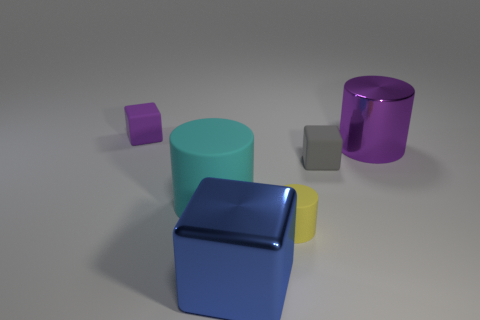Add 3 tiny yellow things. How many objects exist? 9 Subtract all purple cylinders. How many cylinders are left? 2 Subtract 2 cylinders. How many cylinders are left? 1 Subtract all cyan cylinders. How many cylinders are left? 2 Subtract all purple cylinders. Subtract all cyan blocks. How many cylinders are left? 2 Subtract all blue objects. Subtract all small cylinders. How many objects are left? 4 Add 1 small purple cubes. How many small purple cubes are left? 2 Add 1 purple metal cylinders. How many purple metal cylinders exist? 2 Subtract 0 red cylinders. How many objects are left? 6 